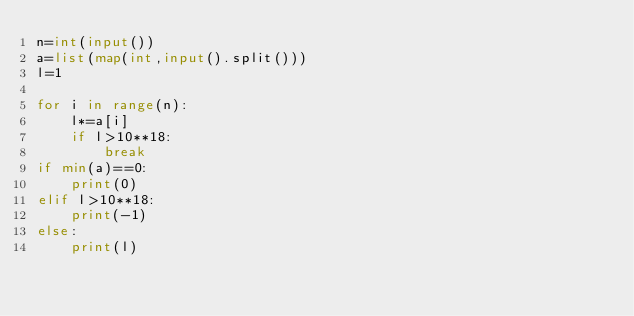Convert code to text. <code><loc_0><loc_0><loc_500><loc_500><_Python_>n=int(input())
a=list(map(int,input().split()))
l=1

for i in range(n):
    l*=a[i]
    if l>10**18:
        break
if min(a)==0:
    print(0)
elif l>10**18:
    print(-1)
else:
    print(l)</code> 